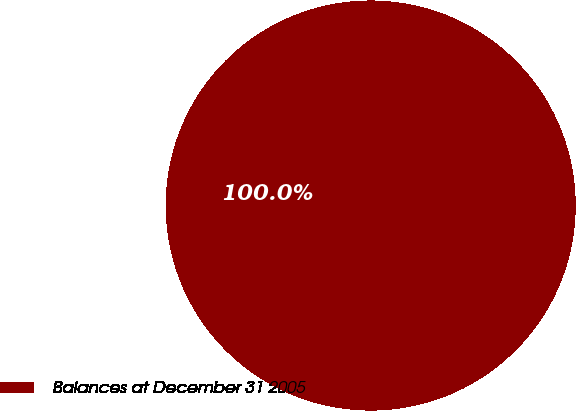Convert chart. <chart><loc_0><loc_0><loc_500><loc_500><pie_chart><fcel>Balances at December 31 2005<nl><fcel>100.0%<nl></chart> 